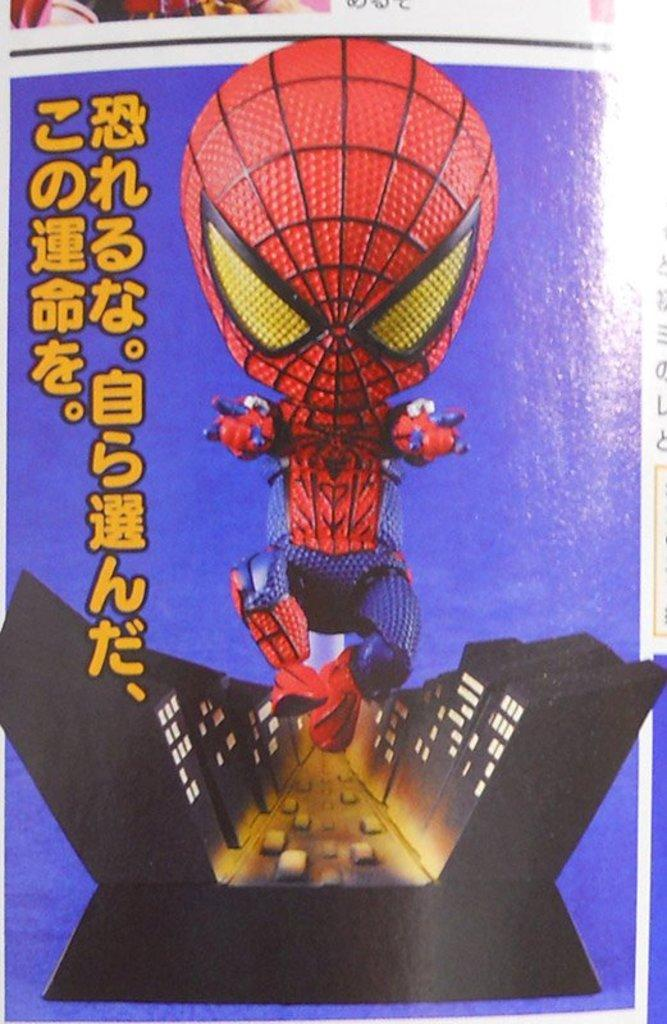What is: What character is featured on the poster in the image? There is a poster of Spider-Man in the image. What else can be seen on the poster besides the character? There are buildings depicted on the poster. Is there any text on the poster? Yes, there is text at the bottom of the poster. Can you tell me how many kites are flying in the image? There are no kites present in the image; it features a poster of Spider-Man with buildings and text. What type of stocking is the character wearing in the image? The character on the poster, Spider-Man, does not wear stockings. 